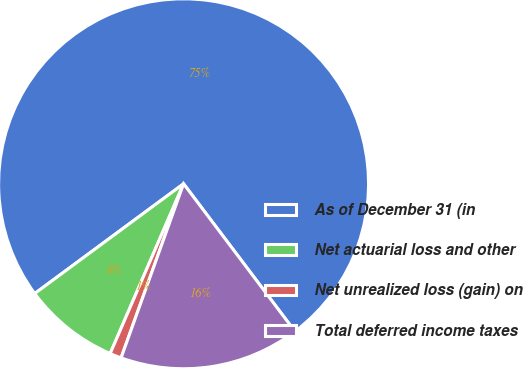Convert chart. <chart><loc_0><loc_0><loc_500><loc_500><pie_chart><fcel>As of December 31 (in<fcel>Net actuarial loss and other<fcel>Net unrealized loss (gain) on<fcel>Total deferred income taxes<nl><fcel>74.82%<fcel>8.39%<fcel>1.01%<fcel>15.77%<nl></chart> 